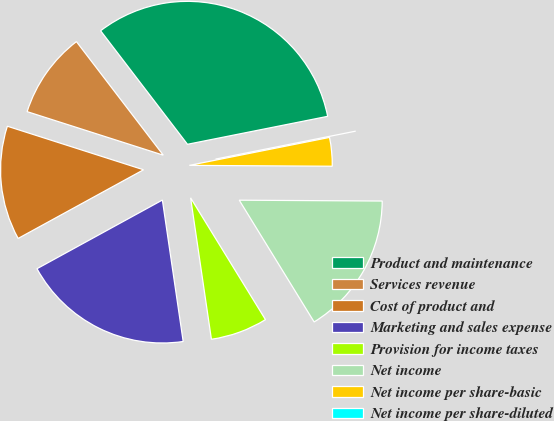Convert chart. <chart><loc_0><loc_0><loc_500><loc_500><pie_chart><fcel>Product and maintenance<fcel>Services revenue<fcel>Cost of product and<fcel>Marketing and sales expense<fcel>Provision for income taxes<fcel>Net income<fcel>Net income per share-basic<fcel>Net income per share-diluted<nl><fcel>32.26%<fcel>9.68%<fcel>12.9%<fcel>19.35%<fcel>6.45%<fcel>16.13%<fcel>3.23%<fcel>0.0%<nl></chart> 